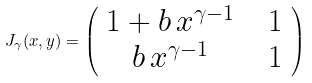Convert formula to latex. <formula><loc_0><loc_0><loc_500><loc_500>J _ { \gamma } ( x , y ) = \left ( \begin{array} { c c c } 1 + b \, x ^ { \gamma - 1 } & & 1 \\ b \, x ^ { \gamma - 1 } & & 1 \\ \end{array} \right )</formula> 